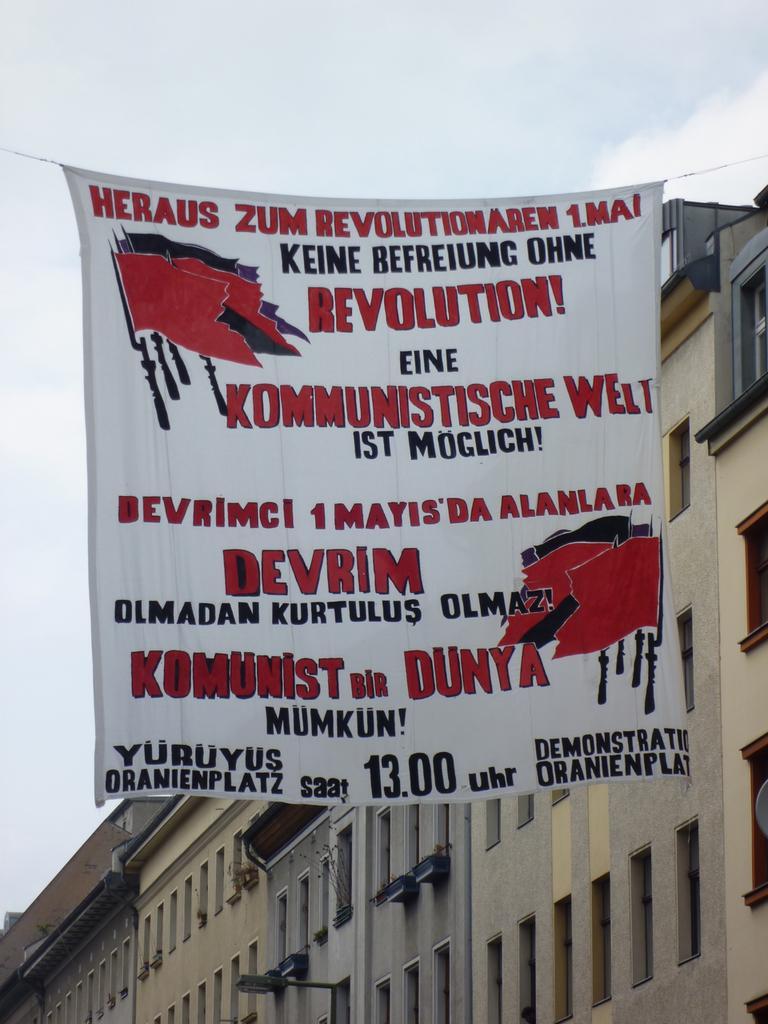Please provide a concise description of this image. In this image, there are a few buildings. We can see a banner with some text and images on it. We can see the sky. 